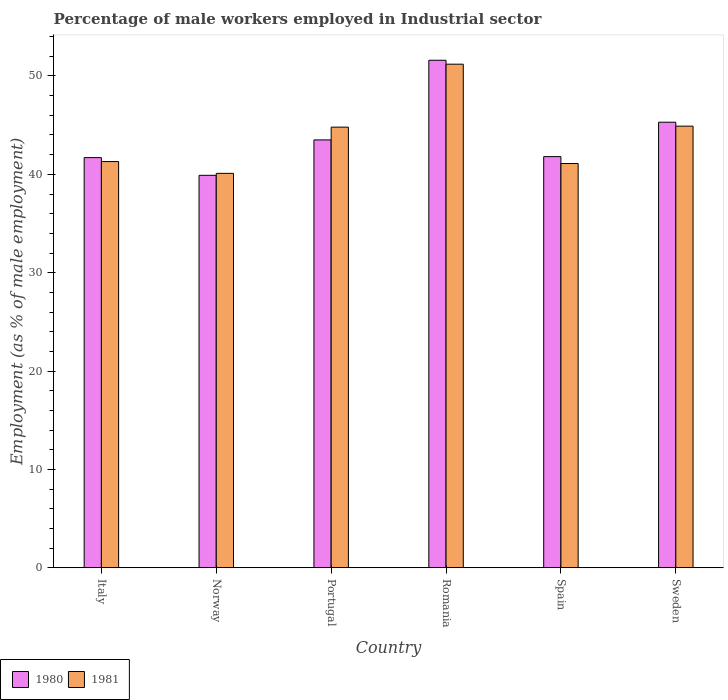How many different coloured bars are there?
Ensure brevity in your answer.  2. What is the label of the 4th group of bars from the left?
Offer a terse response. Romania. What is the percentage of male workers employed in Industrial sector in 1980 in Romania?
Give a very brief answer. 51.6. Across all countries, what is the maximum percentage of male workers employed in Industrial sector in 1981?
Your response must be concise. 51.2. Across all countries, what is the minimum percentage of male workers employed in Industrial sector in 1980?
Offer a terse response. 39.9. In which country was the percentage of male workers employed in Industrial sector in 1980 maximum?
Offer a terse response. Romania. In which country was the percentage of male workers employed in Industrial sector in 1981 minimum?
Make the answer very short. Norway. What is the total percentage of male workers employed in Industrial sector in 1980 in the graph?
Make the answer very short. 263.8. What is the difference between the percentage of male workers employed in Industrial sector in 1980 in Norway and that in Portugal?
Provide a succinct answer. -3.6. What is the difference between the percentage of male workers employed in Industrial sector in 1980 in Portugal and the percentage of male workers employed in Industrial sector in 1981 in Norway?
Provide a short and direct response. 3.4. What is the average percentage of male workers employed in Industrial sector in 1980 per country?
Your answer should be very brief. 43.97. What is the difference between the percentage of male workers employed in Industrial sector of/in 1980 and percentage of male workers employed in Industrial sector of/in 1981 in Spain?
Give a very brief answer. 0.7. What is the ratio of the percentage of male workers employed in Industrial sector in 1981 in Norway to that in Portugal?
Give a very brief answer. 0.9. Is the percentage of male workers employed in Industrial sector in 1981 in Spain less than that in Sweden?
Your answer should be very brief. Yes. Is the difference between the percentage of male workers employed in Industrial sector in 1980 in Spain and Sweden greater than the difference between the percentage of male workers employed in Industrial sector in 1981 in Spain and Sweden?
Your answer should be compact. Yes. What is the difference between the highest and the second highest percentage of male workers employed in Industrial sector in 1980?
Keep it short and to the point. -8.1. What is the difference between the highest and the lowest percentage of male workers employed in Industrial sector in 1980?
Offer a very short reply. 11.7. What does the 2nd bar from the left in Norway represents?
Your answer should be very brief. 1981. What does the 1st bar from the right in Spain represents?
Offer a very short reply. 1981. Are all the bars in the graph horizontal?
Your answer should be compact. No. How many countries are there in the graph?
Offer a very short reply. 6. Are the values on the major ticks of Y-axis written in scientific E-notation?
Ensure brevity in your answer.  No. Where does the legend appear in the graph?
Provide a short and direct response. Bottom left. How many legend labels are there?
Make the answer very short. 2. How are the legend labels stacked?
Provide a short and direct response. Horizontal. What is the title of the graph?
Make the answer very short. Percentage of male workers employed in Industrial sector. Does "1985" appear as one of the legend labels in the graph?
Your response must be concise. No. What is the label or title of the X-axis?
Give a very brief answer. Country. What is the label or title of the Y-axis?
Provide a short and direct response. Employment (as % of male employment). What is the Employment (as % of male employment) of 1980 in Italy?
Ensure brevity in your answer.  41.7. What is the Employment (as % of male employment) of 1981 in Italy?
Provide a short and direct response. 41.3. What is the Employment (as % of male employment) in 1980 in Norway?
Offer a very short reply. 39.9. What is the Employment (as % of male employment) of 1981 in Norway?
Give a very brief answer. 40.1. What is the Employment (as % of male employment) of 1980 in Portugal?
Provide a short and direct response. 43.5. What is the Employment (as % of male employment) of 1981 in Portugal?
Your answer should be very brief. 44.8. What is the Employment (as % of male employment) of 1980 in Romania?
Make the answer very short. 51.6. What is the Employment (as % of male employment) in 1981 in Romania?
Your response must be concise. 51.2. What is the Employment (as % of male employment) of 1980 in Spain?
Provide a succinct answer. 41.8. What is the Employment (as % of male employment) of 1981 in Spain?
Your answer should be very brief. 41.1. What is the Employment (as % of male employment) of 1980 in Sweden?
Your response must be concise. 45.3. What is the Employment (as % of male employment) of 1981 in Sweden?
Offer a very short reply. 44.9. Across all countries, what is the maximum Employment (as % of male employment) of 1980?
Ensure brevity in your answer.  51.6. Across all countries, what is the maximum Employment (as % of male employment) in 1981?
Provide a short and direct response. 51.2. Across all countries, what is the minimum Employment (as % of male employment) of 1980?
Make the answer very short. 39.9. Across all countries, what is the minimum Employment (as % of male employment) of 1981?
Offer a very short reply. 40.1. What is the total Employment (as % of male employment) in 1980 in the graph?
Provide a succinct answer. 263.8. What is the total Employment (as % of male employment) of 1981 in the graph?
Your answer should be compact. 263.4. What is the difference between the Employment (as % of male employment) in 1980 in Italy and that in Portugal?
Your answer should be very brief. -1.8. What is the difference between the Employment (as % of male employment) in 1981 in Italy and that in Spain?
Give a very brief answer. 0.2. What is the difference between the Employment (as % of male employment) of 1980 in Italy and that in Sweden?
Make the answer very short. -3.6. What is the difference between the Employment (as % of male employment) in 1981 in Italy and that in Sweden?
Provide a succinct answer. -3.6. What is the difference between the Employment (as % of male employment) in 1981 in Norway and that in Portugal?
Offer a very short reply. -4.7. What is the difference between the Employment (as % of male employment) of 1980 in Norway and that in Romania?
Keep it short and to the point. -11.7. What is the difference between the Employment (as % of male employment) of 1981 in Norway and that in Romania?
Make the answer very short. -11.1. What is the difference between the Employment (as % of male employment) of 1980 in Norway and that in Spain?
Keep it short and to the point. -1.9. What is the difference between the Employment (as % of male employment) of 1981 in Norway and that in Spain?
Keep it short and to the point. -1. What is the difference between the Employment (as % of male employment) of 1980 in Norway and that in Sweden?
Provide a succinct answer. -5.4. What is the difference between the Employment (as % of male employment) of 1980 in Portugal and that in Romania?
Provide a short and direct response. -8.1. What is the difference between the Employment (as % of male employment) in 1980 in Portugal and that in Spain?
Keep it short and to the point. 1.7. What is the difference between the Employment (as % of male employment) in 1981 in Portugal and that in Spain?
Your answer should be compact. 3.7. What is the difference between the Employment (as % of male employment) in 1980 in Portugal and that in Sweden?
Your answer should be very brief. -1.8. What is the difference between the Employment (as % of male employment) in 1981 in Portugal and that in Sweden?
Provide a succinct answer. -0.1. What is the difference between the Employment (as % of male employment) in 1980 in Romania and that in Spain?
Keep it short and to the point. 9.8. What is the difference between the Employment (as % of male employment) in 1981 in Romania and that in Spain?
Provide a short and direct response. 10.1. What is the difference between the Employment (as % of male employment) of 1980 in Spain and that in Sweden?
Make the answer very short. -3.5. What is the difference between the Employment (as % of male employment) in 1980 in Italy and the Employment (as % of male employment) in 1981 in Portugal?
Provide a short and direct response. -3.1. What is the difference between the Employment (as % of male employment) of 1980 in Italy and the Employment (as % of male employment) of 1981 in Spain?
Offer a terse response. 0.6. What is the difference between the Employment (as % of male employment) of 1980 in Italy and the Employment (as % of male employment) of 1981 in Sweden?
Offer a very short reply. -3.2. What is the difference between the Employment (as % of male employment) in 1980 in Norway and the Employment (as % of male employment) in 1981 in Romania?
Offer a very short reply. -11.3. What is the difference between the Employment (as % of male employment) of 1980 in Norway and the Employment (as % of male employment) of 1981 in Sweden?
Make the answer very short. -5. What is the difference between the Employment (as % of male employment) of 1980 in Portugal and the Employment (as % of male employment) of 1981 in Spain?
Your response must be concise. 2.4. What is the difference between the Employment (as % of male employment) of 1980 in Romania and the Employment (as % of male employment) of 1981 in Sweden?
Provide a short and direct response. 6.7. What is the average Employment (as % of male employment) in 1980 per country?
Offer a very short reply. 43.97. What is the average Employment (as % of male employment) in 1981 per country?
Your response must be concise. 43.9. What is the difference between the Employment (as % of male employment) in 1980 and Employment (as % of male employment) in 1981 in Norway?
Provide a short and direct response. -0.2. What is the difference between the Employment (as % of male employment) of 1980 and Employment (as % of male employment) of 1981 in Spain?
Offer a very short reply. 0.7. What is the ratio of the Employment (as % of male employment) in 1980 in Italy to that in Norway?
Give a very brief answer. 1.05. What is the ratio of the Employment (as % of male employment) in 1981 in Italy to that in Norway?
Give a very brief answer. 1.03. What is the ratio of the Employment (as % of male employment) of 1980 in Italy to that in Portugal?
Keep it short and to the point. 0.96. What is the ratio of the Employment (as % of male employment) in 1981 in Italy to that in Portugal?
Provide a short and direct response. 0.92. What is the ratio of the Employment (as % of male employment) of 1980 in Italy to that in Romania?
Ensure brevity in your answer.  0.81. What is the ratio of the Employment (as % of male employment) of 1981 in Italy to that in Romania?
Offer a terse response. 0.81. What is the ratio of the Employment (as % of male employment) in 1981 in Italy to that in Spain?
Your answer should be compact. 1. What is the ratio of the Employment (as % of male employment) in 1980 in Italy to that in Sweden?
Ensure brevity in your answer.  0.92. What is the ratio of the Employment (as % of male employment) in 1981 in Italy to that in Sweden?
Ensure brevity in your answer.  0.92. What is the ratio of the Employment (as % of male employment) in 1980 in Norway to that in Portugal?
Your answer should be very brief. 0.92. What is the ratio of the Employment (as % of male employment) in 1981 in Norway to that in Portugal?
Your answer should be very brief. 0.9. What is the ratio of the Employment (as % of male employment) in 1980 in Norway to that in Romania?
Offer a terse response. 0.77. What is the ratio of the Employment (as % of male employment) of 1981 in Norway to that in Romania?
Offer a terse response. 0.78. What is the ratio of the Employment (as % of male employment) in 1980 in Norway to that in Spain?
Make the answer very short. 0.95. What is the ratio of the Employment (as % of male employment) in 1981 in Norway to that in Spain?
Your answer should be very brief. 0.98. What is the ratio of the Employment (as % of male employment) of 1980 in Norway to that in Sweden?
Give a very brief answer. 0.88. What is the ratio of the Employment (as % of male employment) in 1981 in Norway to that in Sweden?
Keep it short and to the point. 0.89. What is the ratio of the Employment (as % of male employment) in 1980 in Portugal to that in Romania?
Keep it short and to the point. 0.84. What is the ratio of the Employment (as % of male employment) of 1980 in Portugal to that in Spain?
Your answer should be very brief. 1.04. What is the ratio of the Employment (as % of male employment) in 1981 in Portugal to that in Spain?
Offer a terse response. 1.09. What is the ratio of the Employment (as % of male employment) in 1980 in Portugal to that in Sweden?
Offer a very short reply. 0.96. What is the ratio of the Employment (as % of male employment) of 1980 in Romania to that in Spain?
Your answer should be compact. 1.23. What is the ratio of the Employment (as % of male employment) of 1981 in Romania to that in Spain?
Provide a succinct answer. 1.25. What is the ratio of the Employment (as % of male employment) of 1980 in Romania to that in Sweden?
Keep it short and to the point. 1.14. What is the ratio of the Employment (as % of male employment) in 1981 in Romania to that in Sweden?
Your answer should be compact. 1.14. What is the ratio of the Employment (as % of male employment) of 1980 in Spain to that in Sweden?
Provide a short and direct response. 0.92. What is the ratio of the Employment (as % of male employment) of 1981 in Spain to that in Sweden?
Offer a terse response. 0.92. What is the difference between the highest and the second highest Employment (as % of male employment) in 1980?
Offer a very short reply. 6.3. What is the difference between the highest and the second highest Employment (as % of male employment) of 1981?
Your answer should be compact. 6.3. What is the difference between the highest and the lowest Employment (as % of male employment) of 1980?
Your answer should be very brief. 11.7. 